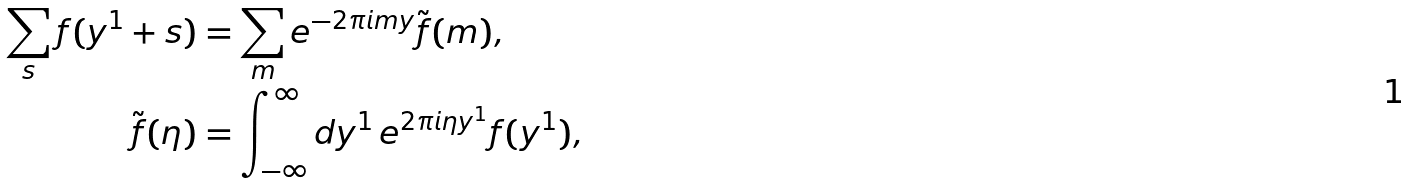Convert formula to latex. <formula><loc_0><loc_0><loc_500><loc_500>\sum _ { s } f ( y ^ { 1 } + s ) & = \sum _ { m } e ^ { - 2 \pi i m y } \tilde { f } ( m ) , \\ \tilde { f } ( \eta ) & = \int _ { - \infty } ^ { \infty } d y ^ { 1 } \, e ^ { 2 \pi i \eta y ^ { 1 } } f ( y ^ { 1 } ) ,</formula> 